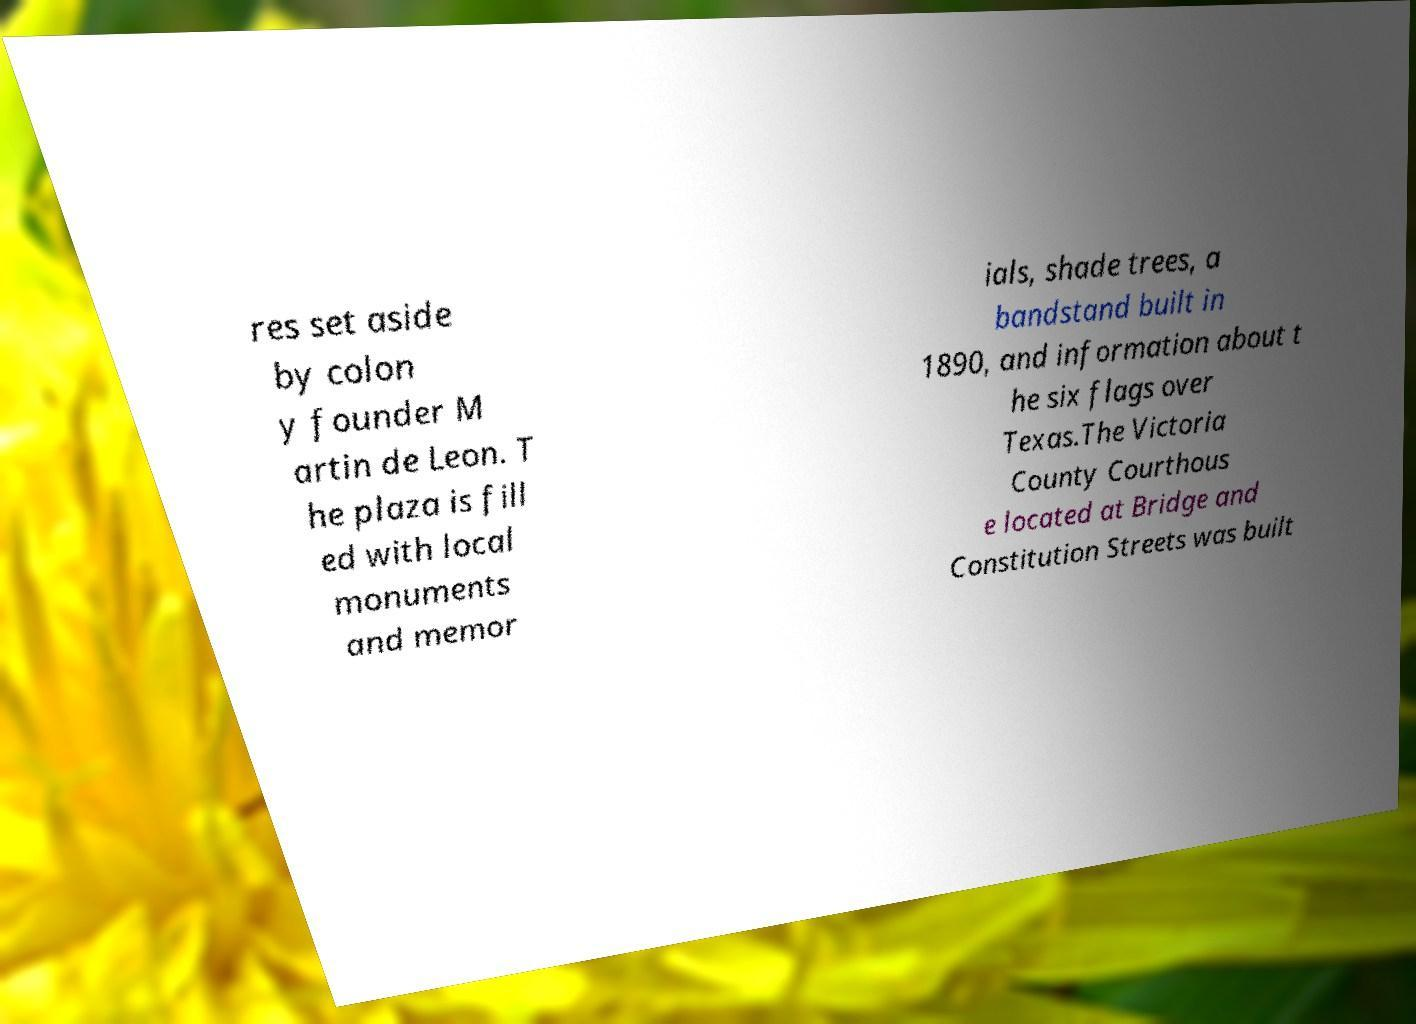Can you read and provide the text displayed in the image?This photo seems to have some interesting text. Can you extract and type it out for me? res set aside by colon y founder M artin de Leon. T he plaza is fill ed with local monuments and memor ials, shade trees, a bandstand built in 1890, and information about t he six flags over Texas.The Victoria County Courthous e located at Bridge and Constitution Streets was built 